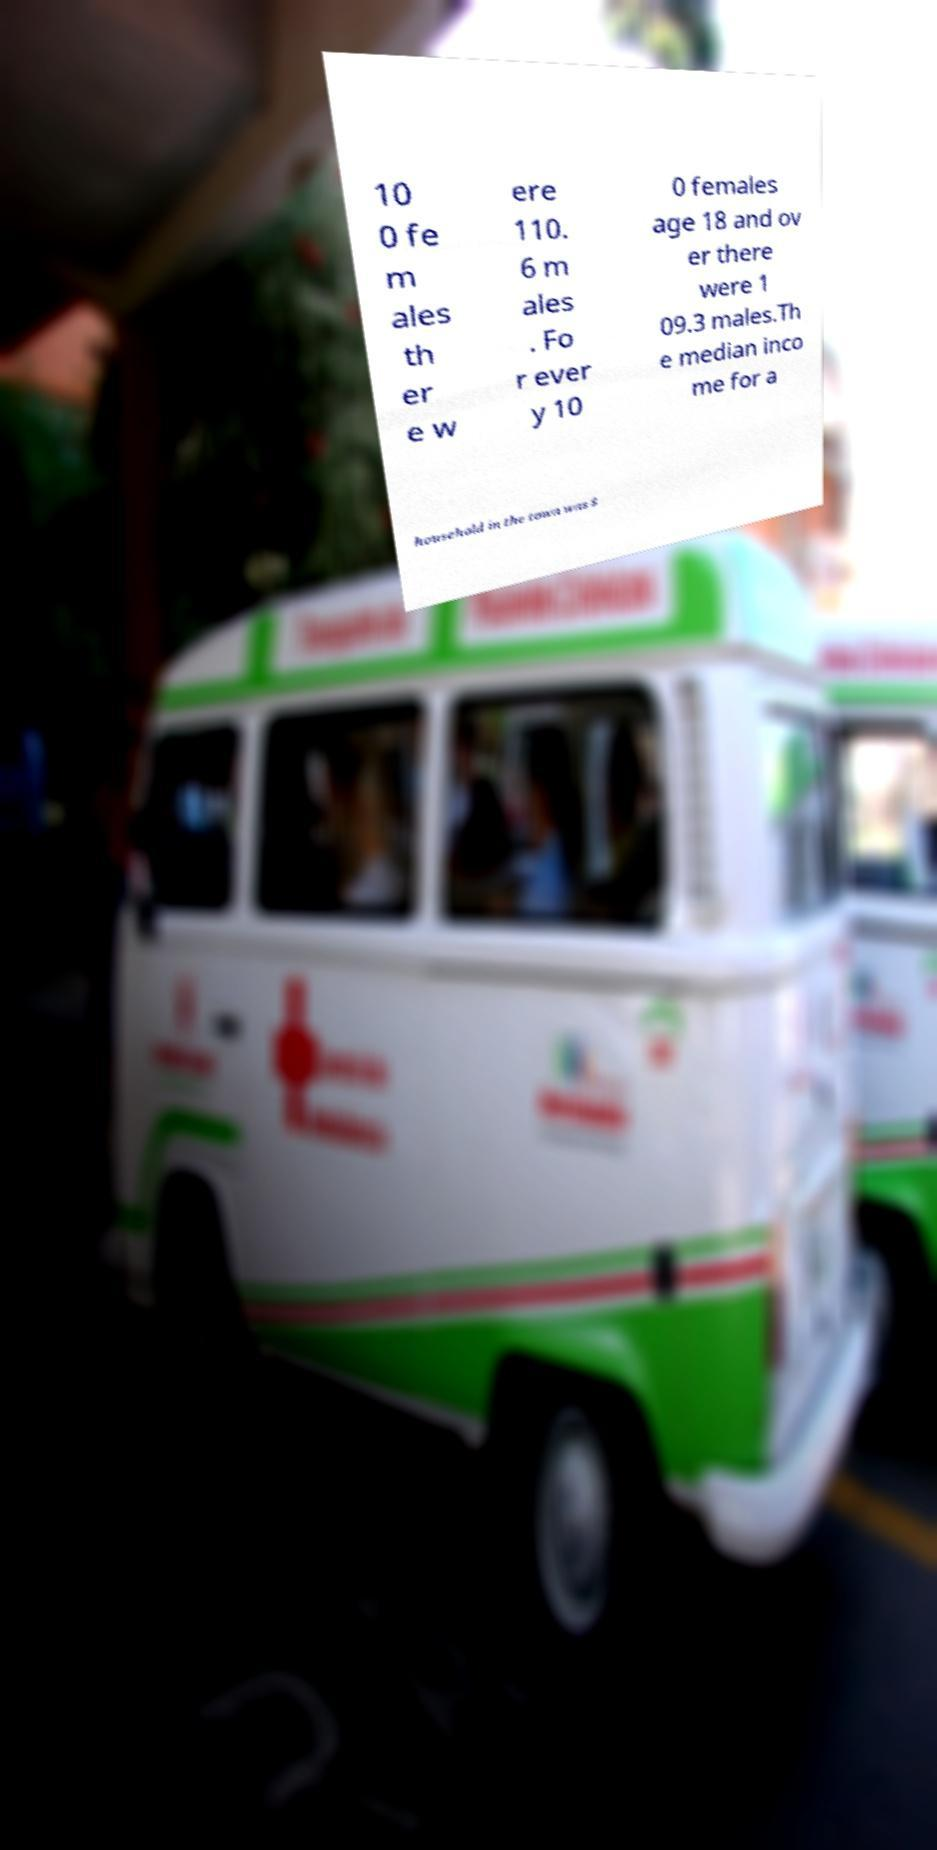I need the written content from this picture converted into text. Can you do that? 10 0 fe m ales th er e w ere 110. 6 m ales . Fo r ever y 10 0 females age 18 and ov er there were 1 09.3 males.Th e median inco me for a household in the town was $ 